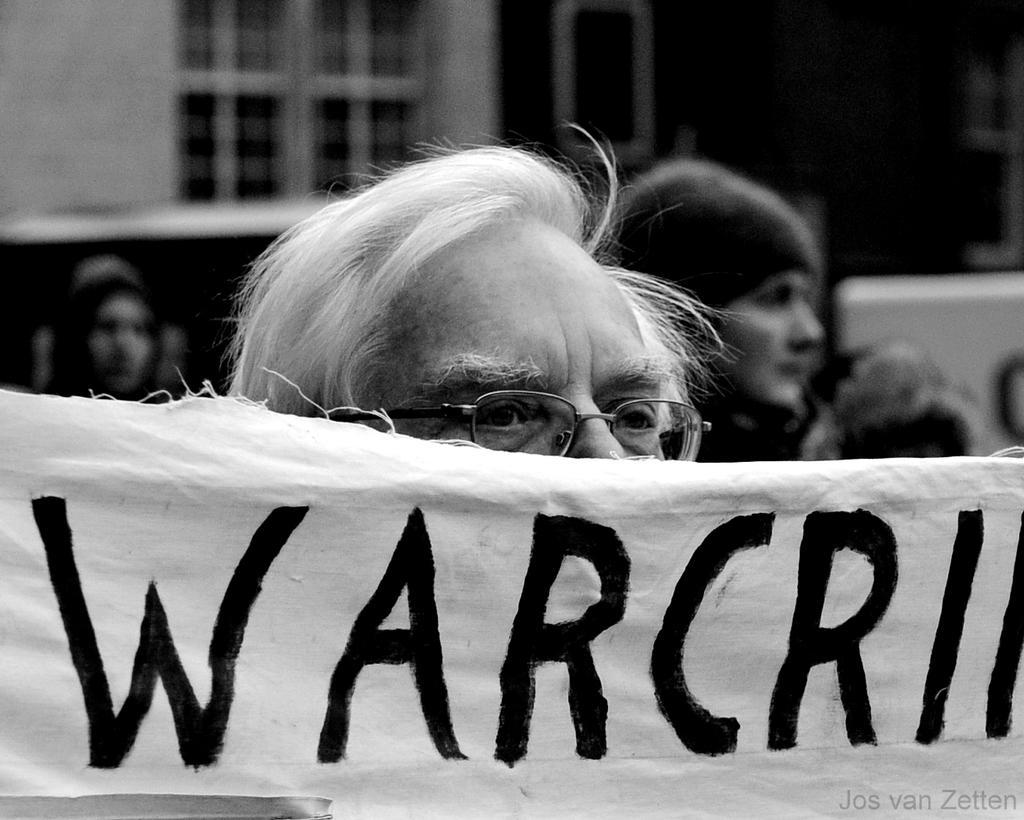Can you describe this image briefly? In this image we can see persons, advertisement and windows. 